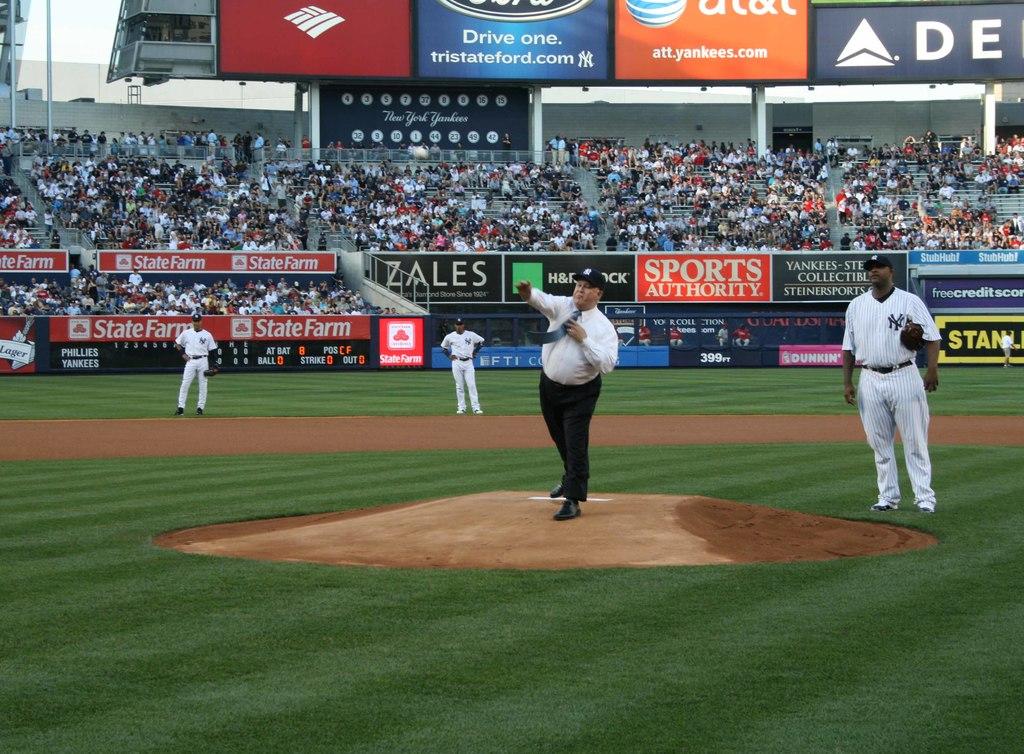What fewelry company sponsors the game?
Keep it short and to the point. Zales. 